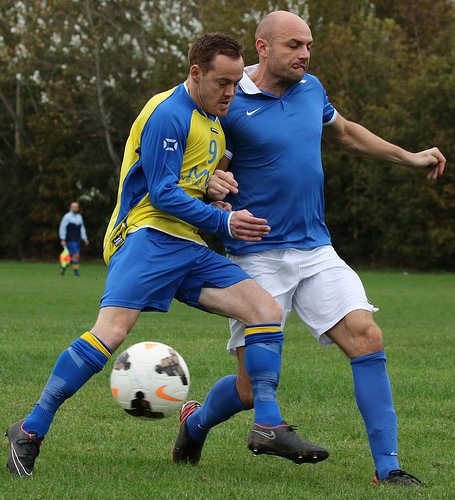<image>
Can you confirm if the shirt is on the man? No. The shirt is not positioned on the man. They may be near each other, but the shirt is not supported by or resting on top of the man. Is the man to the left of the man? Yes. From this viewpoint, the man is positioned to the left side relative to the man. Where is the man in relation to the ball? Is it to the left of the ball? No. The man is not to the left of the ball. From this viewpoint, they have a different horizontal relationship. Is there a tree in front of the ball? No. The tree is not in front of the ball. The spatial positioning shows a different relationship between these objects. 